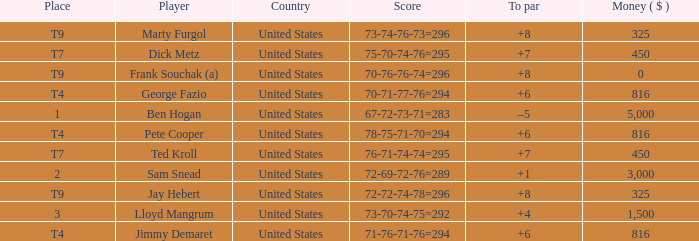Which country is Pete Cooper, who made $816, from? United States. 